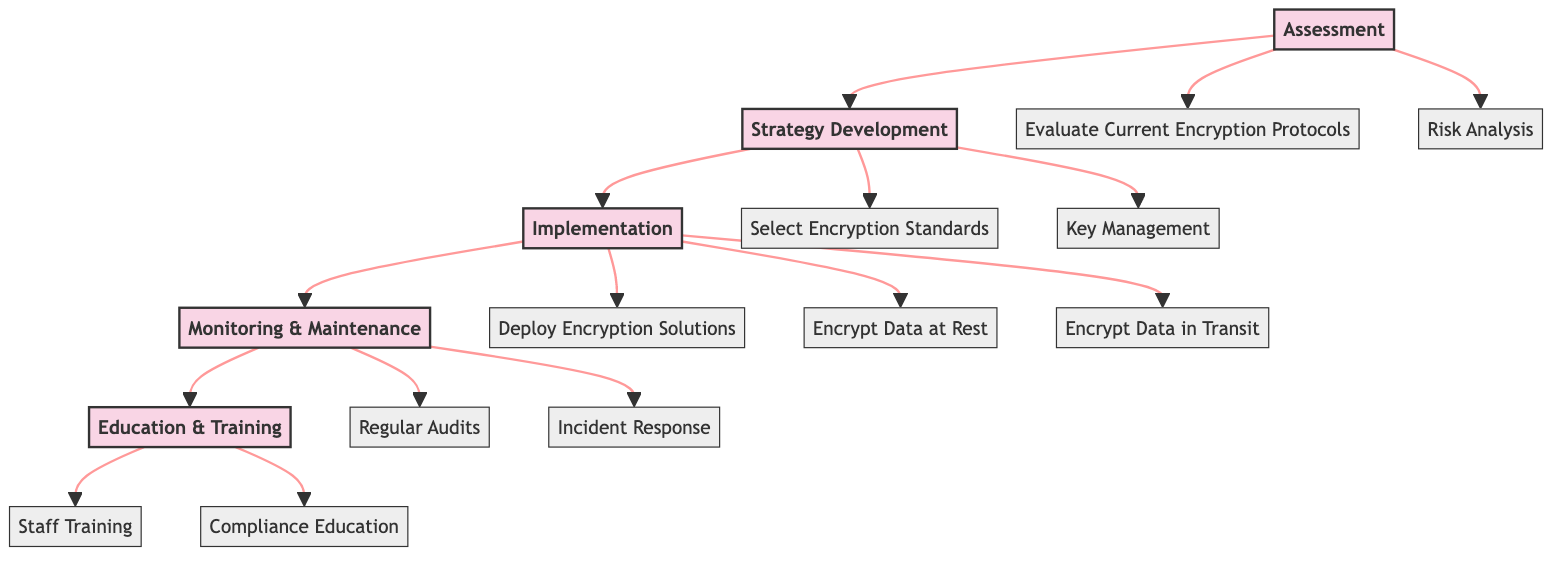How many phases are there in the Clinical Pathway? The diagram indicates five distinct phases, which are Assessment, Strategy Development, Implementation, Monitoring & Maintenance, and Education & Training. Each phase is connected sequentially.
Answer: 5 What is the first step in the Assessment phase? The first step listed under the Assessment phase is "Evaluate Current Encryption Protocols." This step is the initial action performed before any other task in the Clinical Pathway.
Answer: Evaluate Current Encryption Protocols Which step follows "Select Encryption Standards"? Following "Select Encryption Standards," the next step is "Key Management" as indicated by the flow from the Strategy Development phase to its steps.
Answer: Key Management What is the last step in the Implementation phase? The last step in the Implementation phase is "Encrypt Data in Transit," as it is the third step under the Implementation phase in the diagram.
Answer: Encrypt Data in Transit Name a key entity associated with "Regular Audits." The diagram lists "Penetration Testing" and "Compliance Audits" as key entities under the "Regular Audits" step in the Monitoring & Maintenance phase. Either can be accepted as they both relate to this step.
Answer: Penetration Testing How many steps are there in the Monitoring & Maintenance phase? There are two steps listed under the Monitoring & Maintenance phase: "Regular Audits" and "Incident Response." Thus, the total count of steps for this phase is two.
Answer: 2 What is the relationship between the Implementation phase and the strategy development phase? The Implementation phase directly follows the Strategy Development phase, indicating a sequential flow from one phase to the next in the Clinical Pathway, suggesting that implementation occurs after strategy development.
Answer: Directly follows Which phase contains training-related steps? The Education & Training phase contains training-related steps, specifically focused on staff training and compliance education related to encryption practices.
Answer: Education & Training What key entity is associated with the step "Deploy Encryption Solutions"? The key entities associated with "Deploy Encryption Solutions" include "AWS Encryption SDK" and "Google Cloud KMS," indicating tools or services that can be employed in this context.
Answer: AWS Encryption SDK 